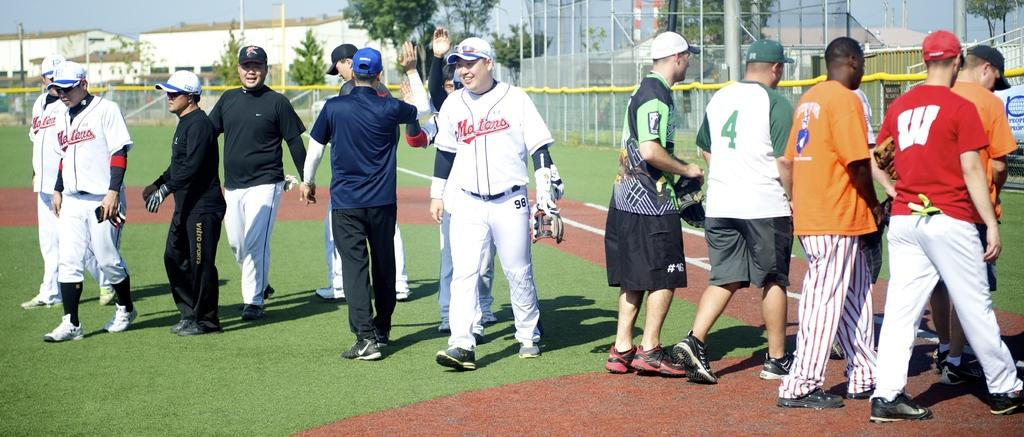<image>
Relay a brief, clear account of the picture shown. A man wearing a Motors jersey in between a bunch of other men on the field 